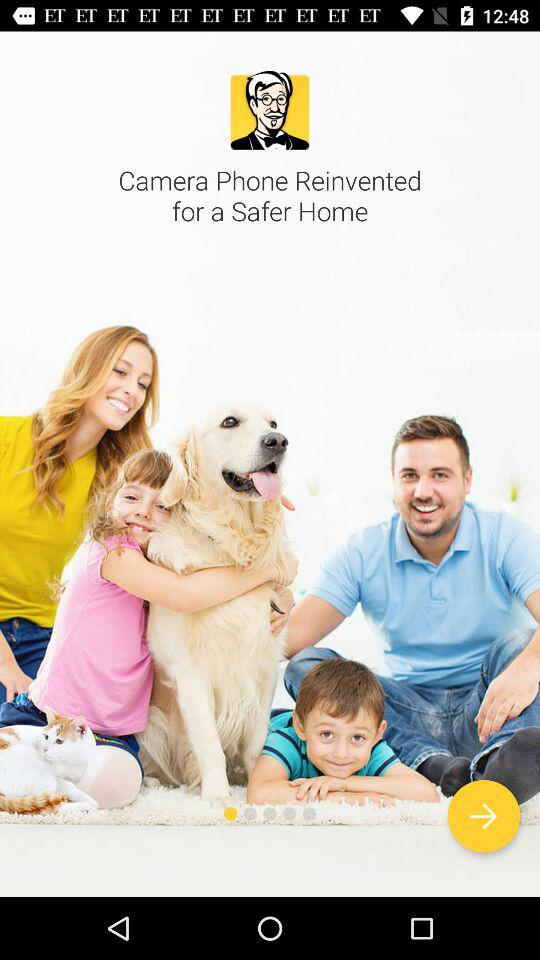What is this application called?
When the provided information is insufficient, respond with <no answer>. <no answer> 